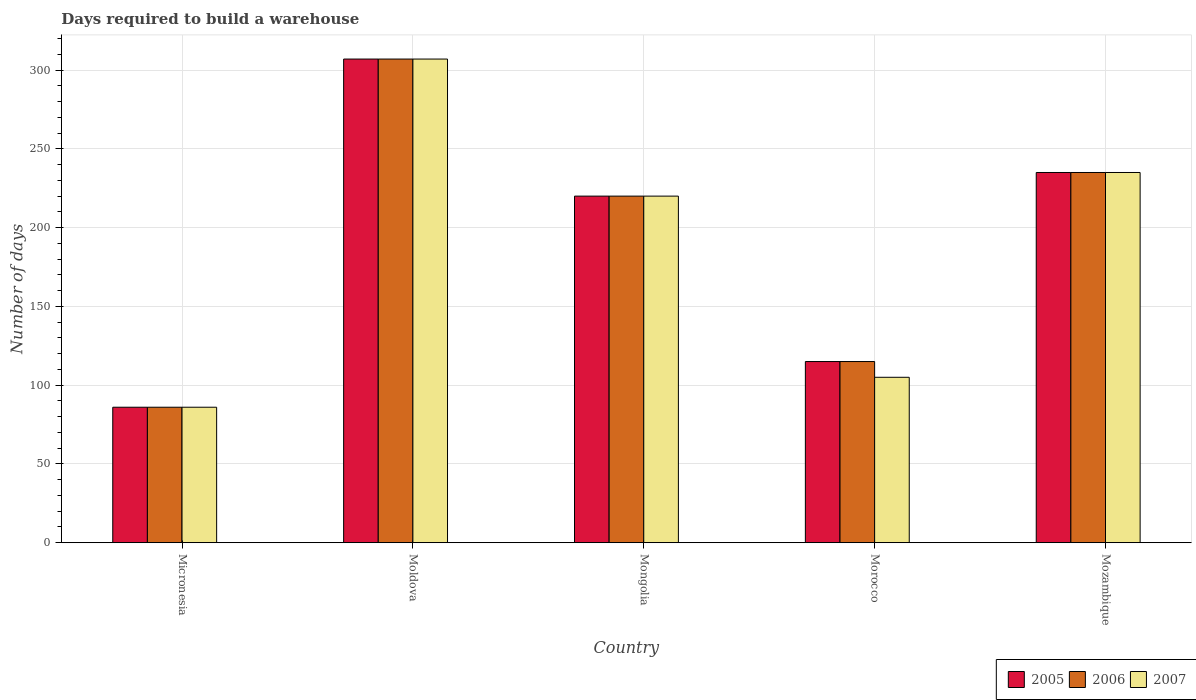How many different coloured bars are there?
Your answer should be compact. 3. How many groups of bars are there?
Your answer should be compact. 5. Are the number of bars on each tick of the X-axis equal?
Give a very brief answer. Yes. How many bars are there on the 2nd tick from the right?
Provide a short and direct response. 3. What is the label of the 5th group of bars from the left?
Give a very brief answer. Mozambique. In how many cases, is the number of bars for a given country not equal to the number of legend labels?
Make the answer very short. 0. What is the days required to build a warehouse in in 2006 in Mongolia?
Ensure brevity in your answer.  220. Across all countries, what is the maximum days required to build a warehouse in in 2005?
Provide a short and direct response. 307. Across all countries, what is the minimum days required to build a warehouse in in 2005?
Your response must be concise. 86. In which country was the days required to build a warehouse in in 2005 maximum?
Keep it short and to the point. Moldova. In which country was the days required to build a warehouse in in 2006 minimum?
Provide a succinct answer. Micronesia. What is the total days required to build a warehouse in in 2007 in the graph?
Offer a terse response. 953. What is the difference between the days required to build a warehouse in in 2007 in Mongolia and that in Morocco?
Offer a terse response. 115. What is the average days required to build a warehouse in in 2006 per country?
Provide a short and direct response. 192.6. What is the difference between the days required to build a warehouse in of/in 2007 and days required to build a warehouse in of/in 2005 in Mozambique?
Your response must be concise. 0. In how many countries, is the days required to build a warehouse in in 2005 greater than 280 days?
Ensure brevity in your answer.  1. What is the ratio of the days required to build a warehouse in in 2007 in Mongolia to that in Morocco?
Keep it short and to the point. 2.1. Is the days required to build a warehouse in in 2005 in Micronesia less than that in Mongolia?
Ensure brevity in your answer.  Yes. Is the difference between the days required to build a warehouse in in 2007 in Micronesia and Mongolia greater than the difference between the days required to build a warehouse in in 2005 in Micronesia and Mongolia?
Your response must be concise. No. What is the difference between the highest and the second highest days required to build a warehouse in in 2005?
Your answer should be compact. 87. What is the difference between the highest and the lowest days required to build a warehouse in in 2005?
Your response must be concise. 221. Is the sum of the days required to build a warehouse in in 2007 in Morocco and Mozambique greater than the maximum days required to build a warehouse in in 2005 across all countries?
Keep it short and to the point. Yes. Is it the case that in every country, the sum of the days required to build a warehouse in in 2005 and days required to build a warehouse in in 2006 is greater than the days required to build a warehouse in in 2007?
Give a very brief answer. Yes. How many bars are there?
Your answer should be compact. 15. What is the difference between two consecutive major ticks on the Y-axis?
Provide a succinct answer. 50. How many legend labels are there?
Keep it short and to the point. 3. What is the title of the graph?
Offer a terse response. Days required to build a warehouse. Does "1961" appear as one of the legend labels in the graph?
Make the answer very short. No. What is the label or title of the Y-axis?
Offer a terse response. Number of days. What is the Number of days of 2005 in Micronesia?
Your answer should be very brief. 86. What is the Number of days of 2007 in Micronesia?
Provide a short and direct response. 86. What is the Number of days in 2005 in Moldova?
Provide a succinct answer. 307. What is the Number of days in 2006 in Moldova?
Provide a succinct answer. 307. What is the Number of days of 2007 in Moldova?
Keep it short and to the point. 307. What is the Number of days in 2005 in Mongolia?
Your response must be concise. 220. What is the Number of days in 2006 in Mongolia?
Provide a short and direct response. 220. What is the Number of days in 2007 in Mongolia?
Your response must be concise. 220. What is the Number of days of 2005 in Morocco?
Offer a very short reply. 115. What is the Number of days of 2006 in Morocco?
Provide a short and direct response. 115. What is the Number of days of 2007 in Morocco?
Provide a short and direct response. 105. What is the Number of days in 2005 in Mozambique?
Provide a succinct answer. 235. What is the Number of days of 2006 in Mozambique?
Give a very brief answer. 235. What is the Number of days in 2007 in Mozambique?
Make the answer very short. 235. Across all countries, what is the maximum Number of days in 2005?
Your response must be concise. 307. Across all countries, what is the maximum Number of days in 2006?
Keep it short and to the point. 307. Across all countries, what is the maximum Number of days of 2007?
Make the answer very short. 307. Across all countries, what is the minimum Number of days of 2005?
Keep it short and to the point. 86. Across all countries, what is the minimum Number of days of 2006?
Keep it short and to the point. 86. What is the total Number of days in 2005 in the graph?
Offer a very short reply. 963. What is the total Number of days of 2006 in the graph?
Your answer should be very brief. 963. What is the total Number of days of 2007 in the graph?
Your response must be concise. 953. What is the difference between the Number of days of 2005 in Micronesia and that in Moldova?
Provide a short and direct response. -221. What is the difference between the Number of days of 2006 in Micronesia and that in Moldova?
Make the answer very short. -221. What is the difference between the Number of days of 2007 in Micronesia and that in Moldova?
Provide a short and direct response. -221. What is the difference between the Number of days in 2005 in Micronesia and that in Mongolia?
Your answer should be compact. -134. What is the difference between the Number of days of 2006 in Micronesia and that in Mongolia?
Make the answer very short. -134. What is the difference between the Number of days in 2007 in Micronesia and that in Mongolia?
Offer a very short reply. -134. What is the difference between the Number of days in 2005 in Micronesia and that in Mozambique?
Your answer should be very brief. -149. What is the difference between the Number of days in 2006 in Micronesia and that in Mozambique?
Provide a short and direct response. -149. What is the difference between the Number of days in 2007 in Micronesia and that in Mozambique?
Ensure brevity in your answer.  -149. What is the difference between the Number of days of 2005 in Moldova and that in Mongolia?
Offer a very short reply. 87. What is the difference between the Number of days of 2006 in Moldova and that in Mongolia?
Offer a terse response. 87. What is the difference between the Number of days of 2007 in Moldova and that in Mongolia?
Ensure brevity in your answer.  87. What is the difference between the Number of days in 2005 in Moldova and that in Morocco?
Ensure brevity in your answer.  192. What is the difference between the Number of days in 2006 in Moldova and that in Morocco?
Keep it short and to the point. 192. What is the difference between the Number of days of 2007 in Moldova and that in Morocco?
Ensure brevity in your answer.  202. What is the difference between the Number of days in 2005 in Moldova and that in Mozambique?
Your answer should be compact. 72. What is the difference between the Number of days of 2005 in Mongolia and that in Morocco?
Offer a very short reply. 105. What is the difference between the Number of days of 2006 in Mongolia and that in Morocco?
Give a very brief answer. 105. What is the difference between the Number of days in 2007 in Mongolia and that in Morocco?
Your answer should be very brief. 115. What is the difference between the Number of days in 2006 in Mongolia and that in Mozambique?
Your answer should be very brief. -15. What is the difference between the Number of days in 2005 in Morocco and that in Mozambique?
Give a very brief answer. -120. What is the difference between the Number of days of 2006 in Morocco and that in Mozambique?
Offer a terse response. -120. What is the difference between the Number of days of 2007 in Morocco and that in Mozambique?
Offer a terse response. -130. What is the difference between the Number of days in 2005 in Micronesia and the Number of days in 2006 in Moldova?
Keep it short and to the point. -221. What is the difference between the Number of days in 2005 in Micronesia and the Number of days in 2007 in Moldova?
Your response must be concise. -221. What is the difference between the Number of days in 2006 in Micronesia and the Number of days in 2007 in Moldova?
Ensure brevity in your answer.  -221. What is the difference between the Number of days of 2005 in Micronesia and the Number of days of 2006 in Mongolia?
Make the answer very short. -134. What is the difference between the Number of days of 2005 in Micronesia and the Number of days of 2007 in Mongolia?
Provide a succinct answer. -134. What is the difference between the Number of days of 2006 in Micronesia and the Number of days of 2007 in Mongolia?
Your response must be concise. -134. What is the difference between the Number of days of 2005 in Micronesia and the Number of days of 2006 in Morocco?
Keep it short and to the point. -29. What is the difference between the Number of days of 2005 in Micronesia and the Number of days of 2007 in Morocco?
Your answer should be very brief. -19. What is the difference between the Number of days of 2005 in Micronesia and the Number of days of 2006 in Mozambique?
Provide a short and direct response. -149. What is the difference between the Number of days of 2005 in Micronesia and the Number of days of 2007 in Mozambique?
Provide a short and direct response. -149. What is the difference between the Number of days in 2006 in Micronesia and the Number of days in 2007 in Mozambique?
Provide a short and direct response. -149. What is the difference between the Number of days in 2005 in Moldova and the Number of days in 2006 in Mongolia?
Offer a terse response. 87. What is the difference between the Number of days in 2005 in Moldova and the Number of days in 2006 in Morocco?
Keep it short and to the point. 192. What is the difference between the Number of days in 2005 in Moldova and the Number of days in 2007 in Morocco?
Provide a succinct answer. 202. What is the difference between the Number of days of 2006 in Moldova and the Number of days of 2007 in Morocco?
Provide a short and direct response. 202. What is the difference between the Number of days of 2005 in Moldova and the Number of days of 2007 in Mozambique?
Give a very brief answer. 72. What is the difference between the Number of days of 2006 in Moldova and the Number of days of 2007 in Mozambique?
Your answer should be compact. 72. What is the difference between the Number of days of 2005 in Mongolia and the Number of days of 2006 in Morocco?
Your answer should be compact. 105. What is the difference between the Number of days of 2005 in Mongolia and the Number of days of 2007 in Morocco?
Offer a very short reply. 115. What is the difference between the Number of days of 2006 in Mongolia and the Number of days of 2007 in Morocco?
Make the answer very short. 115. What is the difference between the Number of days in 2005 in Mongolia and the Number of days in 2007 in Mozambique?
Offer a very short reply. -15. What is the difference between the Number of days of 2005 in Morocco and the Number of days of 2006 in Mozambique?
Your response must be concise. -120. What is the difference between the Number of days of 2005 in Morocco and the Number of days of 2007 in Mozambique?
Provide a succinct answer. -120. What is the difference between the Number of days of 2006 in Morocco and the Number of days of 2007 in Mozambique?
Offer a terse response. -120. What is the average Number of days in 2005 per country?
Provide a succinct answer. 192.6. What is the average Number of days of 2006 per country?
Your answer should be compact. 192.6. What is the average Number of days of 2007 per country?
Offer a terse response. 190.6. What is the difference between the Number of days in 2005 and Number of days in 2006 in Micronesia?
Keep it short and to the point. 0. What is the difference between the Number of days of 2006 and Number of days of 2007 in Micronesia?
Your answer should be very brief. 0. What is the difference between the Number of days of 2005 and Number of days of 2007 in Moldova?
Your answer should be very brief. 0. What is the difference between the Number of days in 2005 and Number of days in 2006 in Mongolia?
Offer a very short reply. 0. What is the difference between the Number of days of 2006 and Number of days of 2007 in Mongolia?
Your answer should be very brief. 0. What is the difference between the Number of days in 2005 and Number of days in 2006 in Morocco?
Make the answer very short. 0. What is the difference between the Number of days in 2005 and Number of days in 2007 in Morocco?
Your answer should be very brief. 10. What is the difference between the Number of days of 2005 and Number of days of 2007 in Mozambique?
Provide a short and direct response. 0. What is the difference between the Number of days in 2006 and Number of days in 2007 in Mozambique?
Provide a succinct answer. 0. What is the ratio of the Number of days in 2005 in Micronesia to that in Moldova?
Keep it short and to the point. 0.28. What is the ratio of the Number of days of 2006 in Micronesia to that in Moldova?
Your answer should be compact. 0.28. What is the ratio of the Number of days in 2007 in Micronesia to that in Moldova?
Your response must be concise. 0.28. What is the ratio of the Number of days in 2005 in Micronesia to that in Mongolia?
Provide a short and direct response. 0.39. What is the ratio of the Number of days of 2006 in Micronesia to that in Mongolia?
Your response must be concise. 0.39. What is the ratio of the Number of days of 2007 in Micronesia to that in Mongolia?
Your answer should be compact. 0.39. What is the ratio of the Number of days in 2005 in Micronesia to that in Morocco?
Provide a short and direct response. 0.75. What is the ratio of the Number of days of 2006 in Micronesia to that in Morocco?
Offer a very short reply. 0.75. What is the ratio of the Number of days in 2007 in Micronesia to that in Morocco?
Provide a succinct answer. 0.82. What is the ratio of the Number of days in 2005 in Micronesia to that in Mozambique?
Your answer should be very brief. 0.37. What is the ratio of the Number of days of 2006 in Micronesia to that in Mozambique?
Provide a short and direct response. 0.37. What is the ratio of the Number of days of 2007 in Micronesia to that in Mozambique?
Keep it short and to the point. 0.37. What is the ratio of the Number of days in 2005 in Moldova to that in Mongolia?
Provide a succinct answer. 1.4. What is the ratio of the Number of days in 2006 in Moldova to that in Mongolia?
Provide a succinct answer. 1.4. What is the ratio of the Number of days of 2007 in Moldova to that in Mongolia?
Your answer should be compact. 1.4. What is the ratio of the Number of days of 2005 in Moldova to that in Morocco?
Your response must be concise. 2.67. What is the ratio of the Number of days of 2006 in Moldova to that in Morocco?
Ensure brevity in your answer.  2.67. What is the ratio of the Number of days of 2007 in Moldova to that in Morocco?
Your response must be concise. 2.92. What is the ratio of the Number of days of 2005 in Moldova to that in Mozambique?
Your answer should be very brief. 1.31. What is the ratio of the Number of days of 2006 in Moldova to that in Mozambique?
Your response must be concise. 1.31. What is the ratio of the Number of days of 2007 in Moldova to that in Mozambique?
Your response must be concise. 1.31. What is the ratio of the Number of days in 2005 in Mongolia to that in Morocco?
Provide a succinct answer. 1.91. What is the ratio of the Number of days in 2006 in Mongolia to that in Morocco?
Ensure brevity in your answer.  1.91. What is the ratio of the Number of days of 2007 in Mongolia to that in Morocco?
Your answer should be compact. 2.1. What is the ratio of the Number of days of 2005 in Mongolia to that in Mozambique?
Ensure brevity in your answer.  0.94. What is the ratio of the Number of days of 2006 in Mongolia to that in Mozambique?
Your answer should be compact. 0.94. What is the ratio of the Number of days in 2007 in Mongolia to that in Mozambique?
Provide a succinct answer. 0.94. What is the ratio of the Number of days of 2005 in Morocco to that in Mozambique?
Provide a succinct answer. 0.49. What is the ratio of the Number of days of 2006 in Morocco to that in Mozambique?
Keep it short and to the point. 0.49. What is the ratio of the Number of days in 2007 in Morocco to that in Mozambique?
Provide a short and direct response. 0.45. What is the difference between the highest and the second highest Number of days of 2005?
Your answer should be very brief. 72. What is the difference between the highest and the second highest Number of days in 2007?
Your answer should be compact. 72. What is the difference between the highest and the lowest Number of days of 2005?
Your answer should be very brief. 221. What is the difference between the highest and the lowest Number of days in 2006?
Make the answer very short. 221. What is the difference between the highest and the lowest Number of days of 2007?
Provide a succinct answer. 221. 